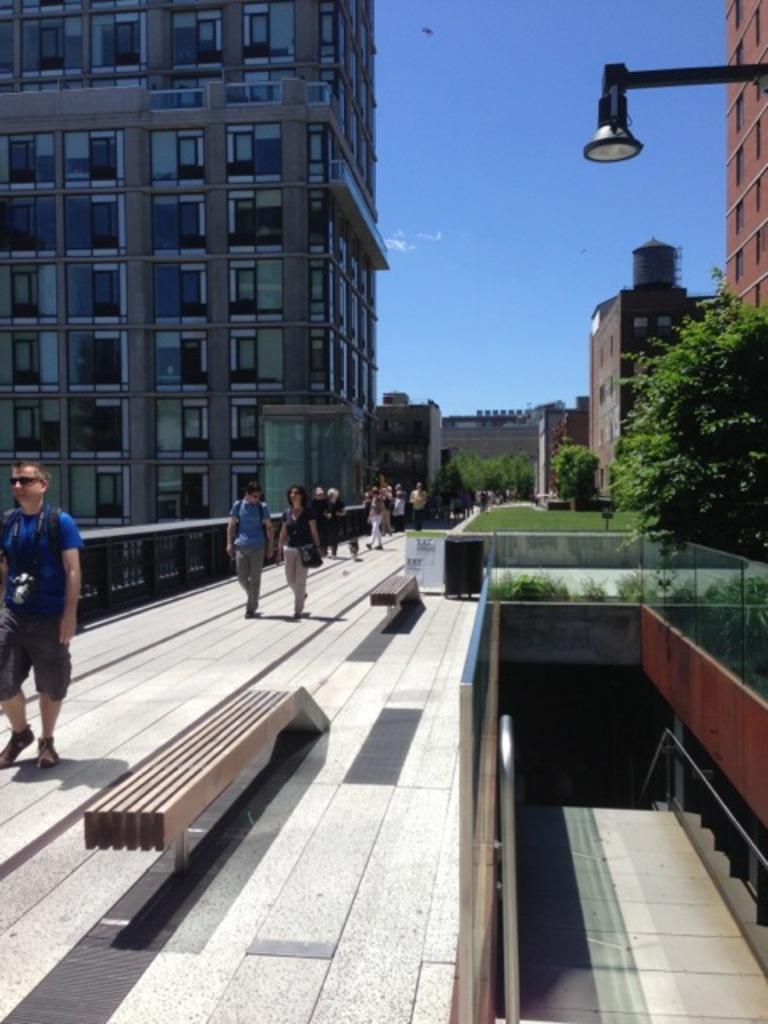Can you describe this image briefly? In this picture we can see a few people and benches on the path. There are glass objects. Through these glass objects, we can see a few trees on the right side. There are a few roads. Some grass is visible on the ground. We can see a few trees, buildings and a light on the right side. There are some buildings and a railing is visible on the left side. Sky is blue in color. We can see an object in the sky. 